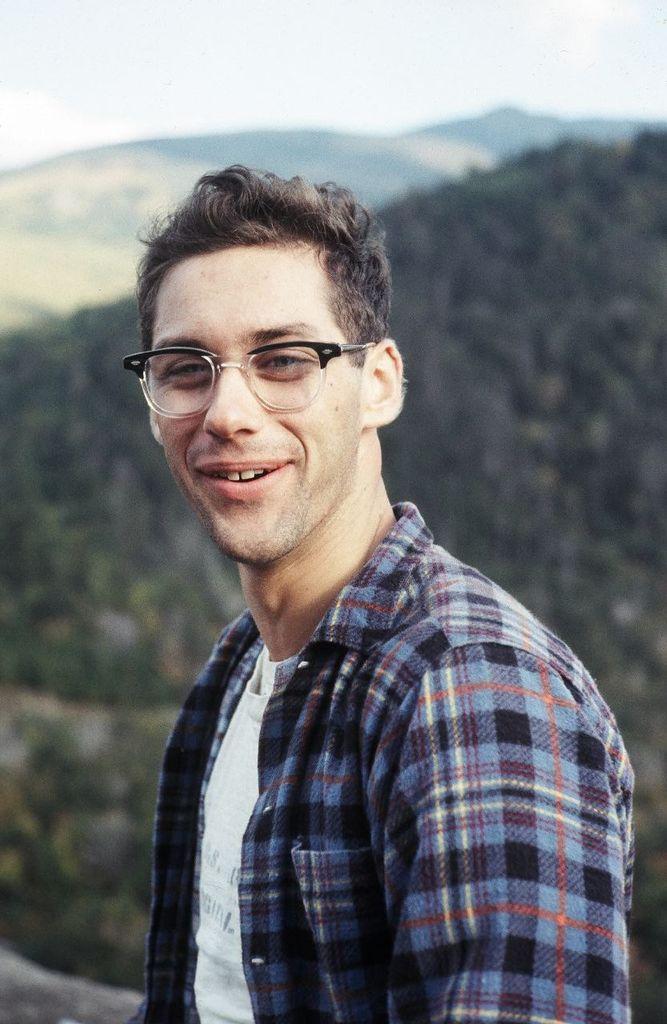Can you describe this image briefly? In this image we can see one person wearing eyeglasses, we can see the hills, at the top we can see the sky. 